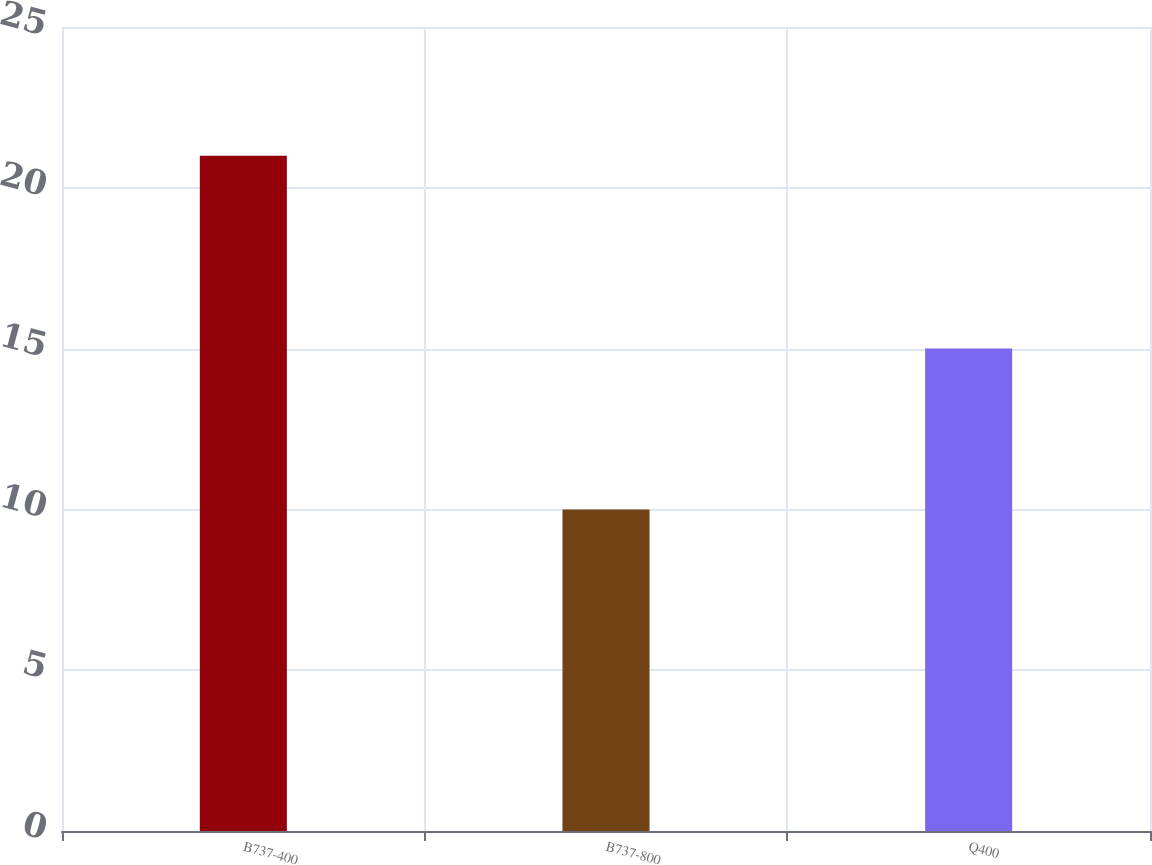<chart> <loc_0><loc_0><loc_500><loc_500><bar_chart><fcel>B737-400<fcel>B737-800<fcel>Q400<nl><fcel>21<fcel>10<fcel>15<nl></chart> 